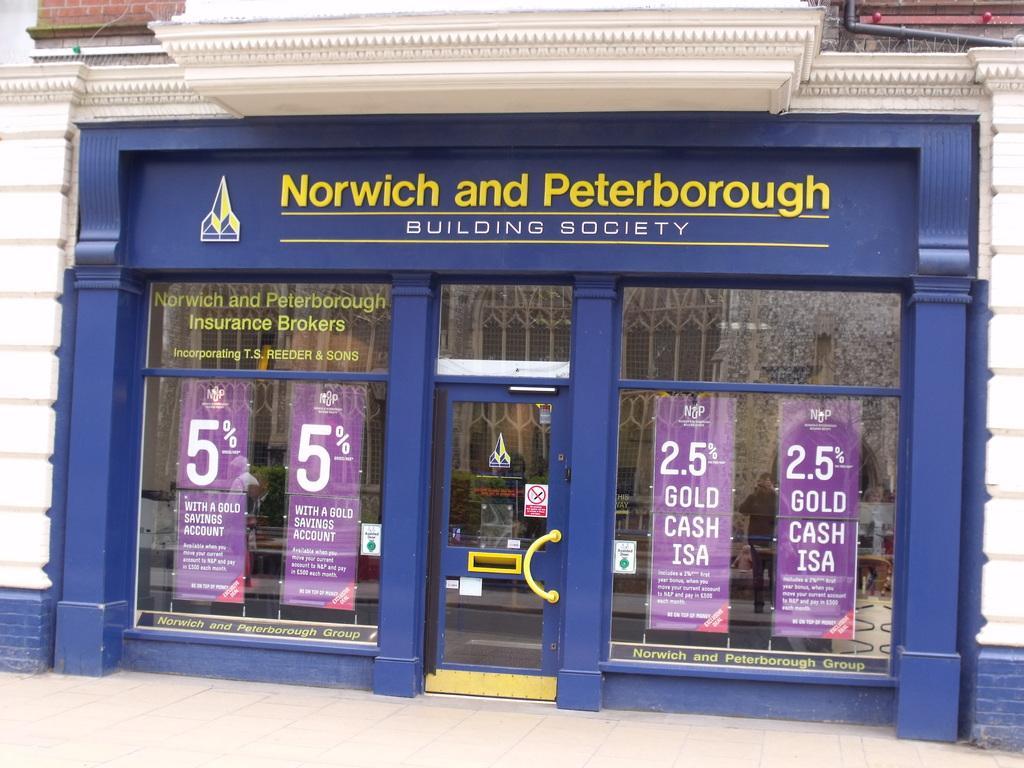Describe this image in one or two sentences. In this picture we can see the building on which we can see some posters. 